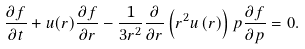Convert formula to latex. <formula><loc_0><loc_0><loc_500><loc_500>\frac { \partial f } { \partial t } + u ( r ) \frac { \partial f } { \partial r } - \frac { 1 } { 3 r ^ { 2 } } \frac { \partial } { \partial r } \left ( r ^ { 2 } u \left ( r \right ) \right ) p \frac { \partial f } { \partial p } = 0 .</formula> 